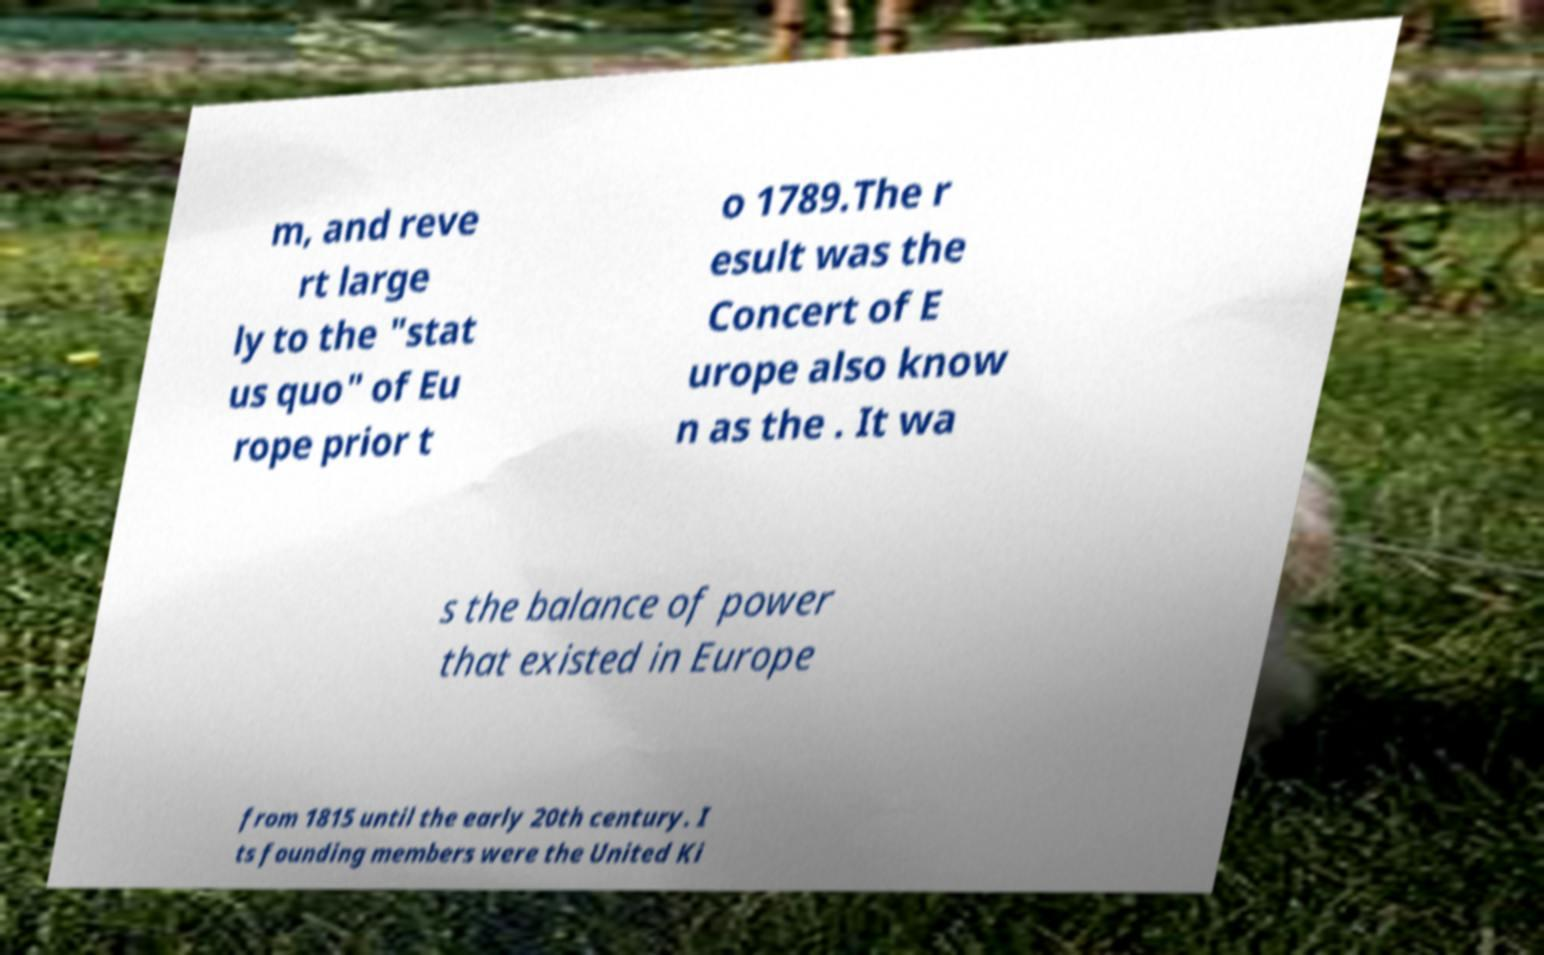Can you read and provide the text displayed in the image?This photo seems to have some interesting text. Can you extract and type it out for me? m, and reve rt large ly to the "stat us quo" of Eu rope prior t o 1789.The r esult was the Concert of E urope also know n as the . It wa s the balance of power that existed in Europe from 1815 until the early 20th century. I ts founding members were the United Ki 